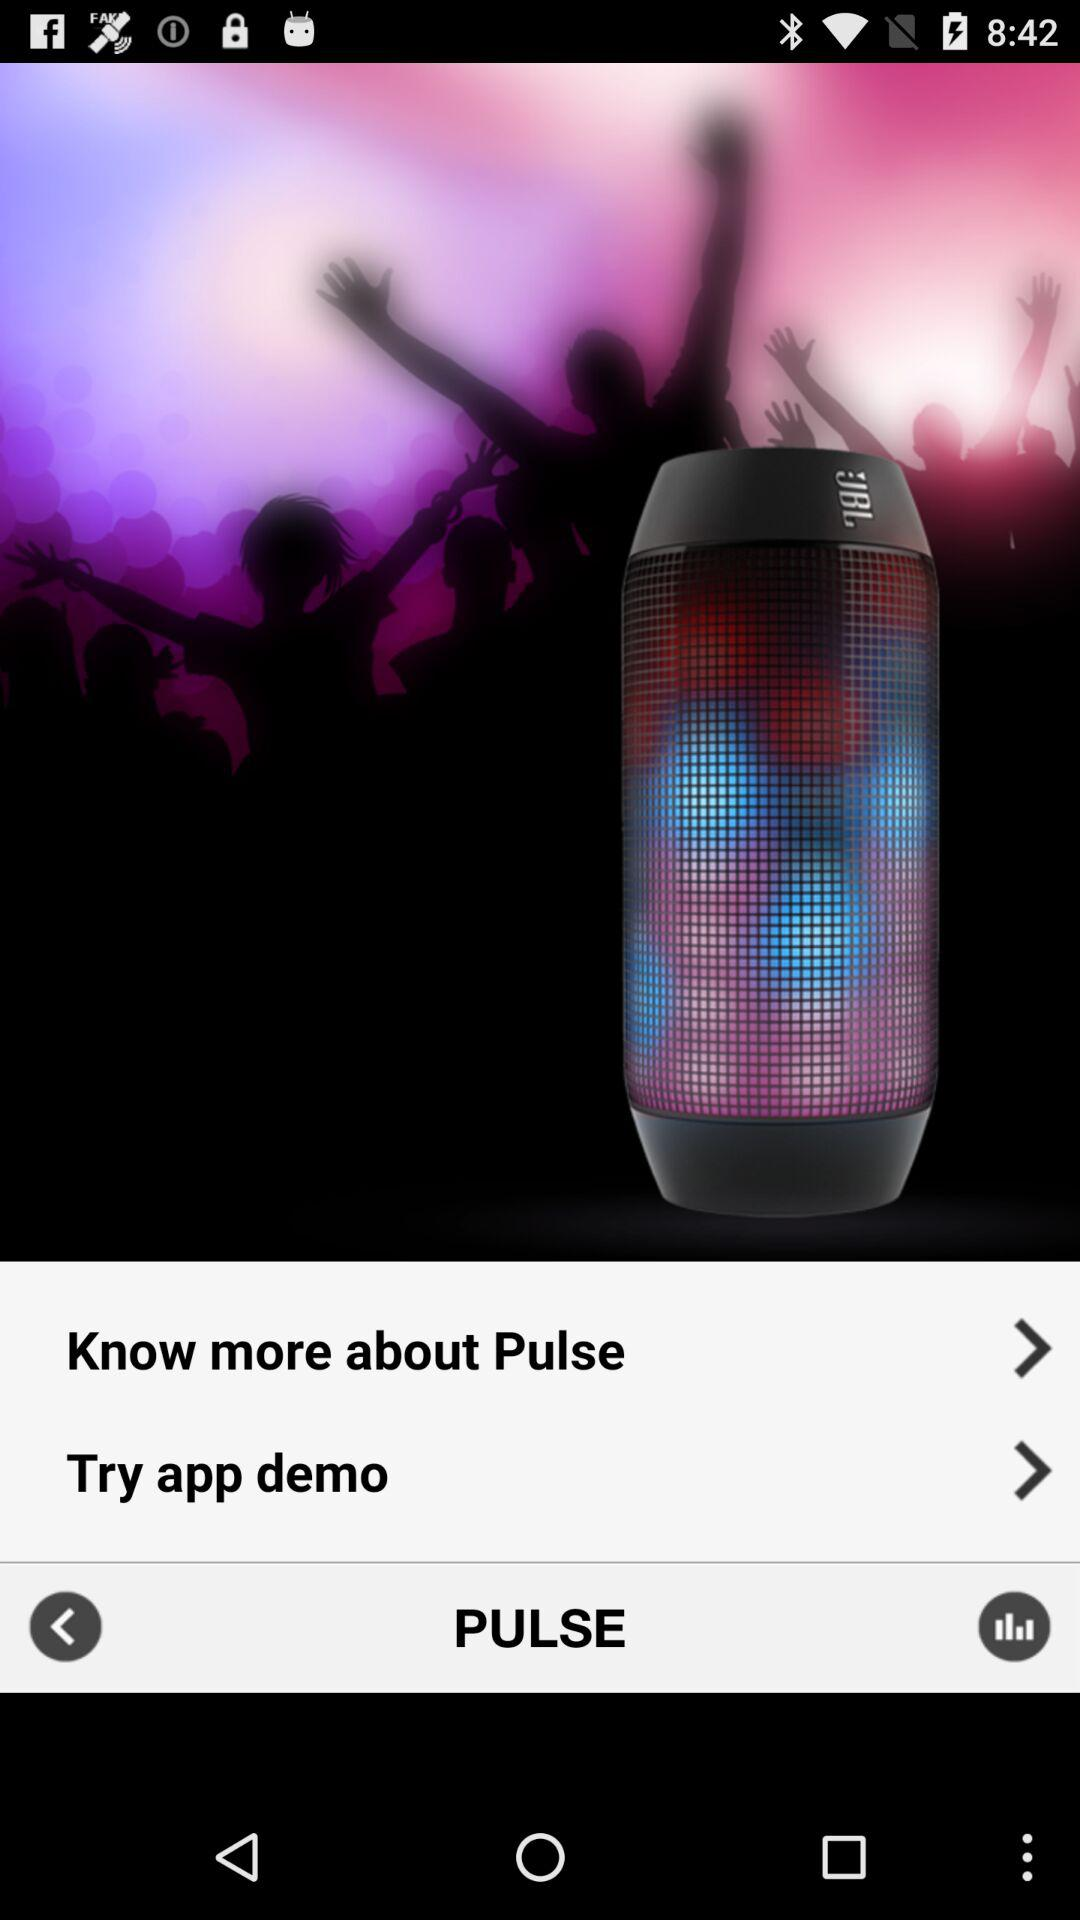What is the application name? The application name is "PULSE". 